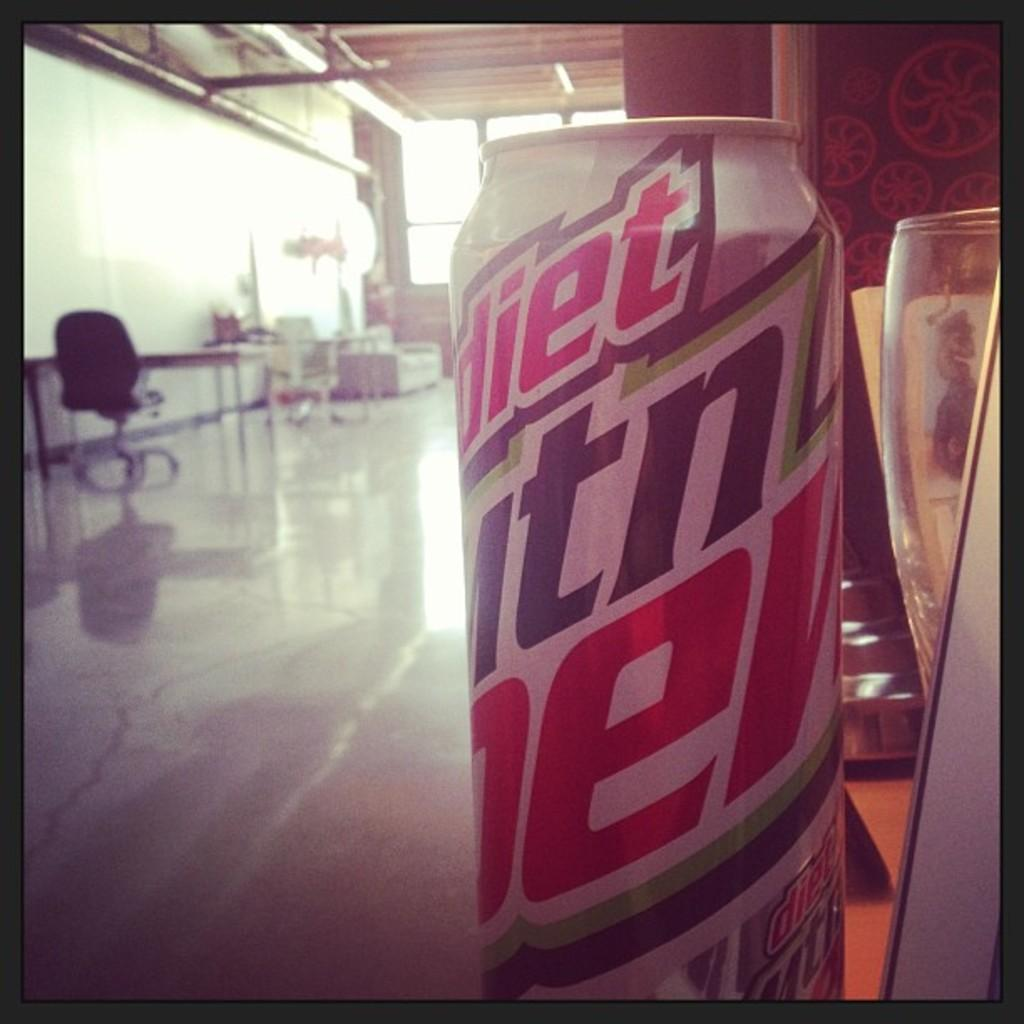<image>
Relay a brief, clear account of the picture shown. A Diet Man Dew soda can sitting on the edge of a table or bar with a glass to the right of it. 